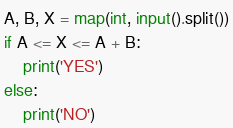<code> <loc_0><loc_0><loc_500><loc_500><_Python_>A, B, X = map(int, input().split())
if A <= X <= A + B:
    print('YES')
else:
    print('NO')</code> 